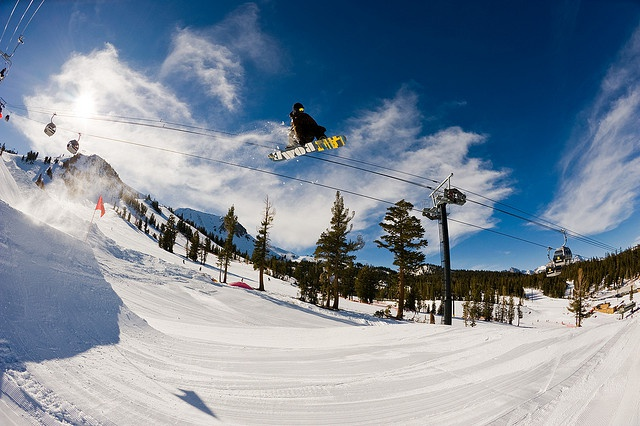Describe the objects in this image and their specific colors. I can see people in darkblue, black, gray, and darkgray tones, snowboard in darkblue, gray, black, ivory, and darkgray tones, people in darkblue, black, maroon, and gray tones, people in darkblue, black, gray, darkgray, and lightgray tones, and people in darkblue, black, darkgray, and gray tones in this image. 